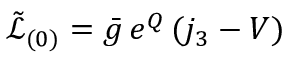Convert formula to latex. <formula><loc_0><loc_0><loc_500><loc_500>\tilde { \mathcal { L } } _ { ( 0 ) } = \bar { g } \, e ^ { Q } \, ( j _ { 3 } - V ) \,</formula> 